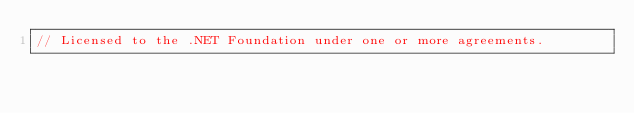<code> <loc_0><loc_0><loc_500><loc_500><_C#_>// Licensed to the .NET Foundation under one or more agreements.</code> 